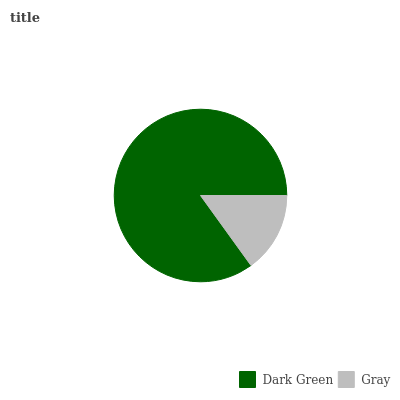Is Gray the minimum?
Answer yes or no. Yes. Is Dark Green the maximum?
Answer yes or no. Yes. Is Gray the maximum?
Answer yes or no. No. Is Dark Green greater than Gray?
Answer yes or no. Yes. Is Gray less than Dark Green?
Answer yes or no. Yes. Is Gray greater than Dark Green?
Answer yes or no. No. Is Dark Green less than Gray?
Answer yes or no. No. Is Dark Green the high median?
Answer yes or no. Yes. Is Gray the low median?
Answer yes or no. Yes. Is Gray the high median?
Answer yes or no. No. Is Dark Green the low median?
Answer yes or no. No. 